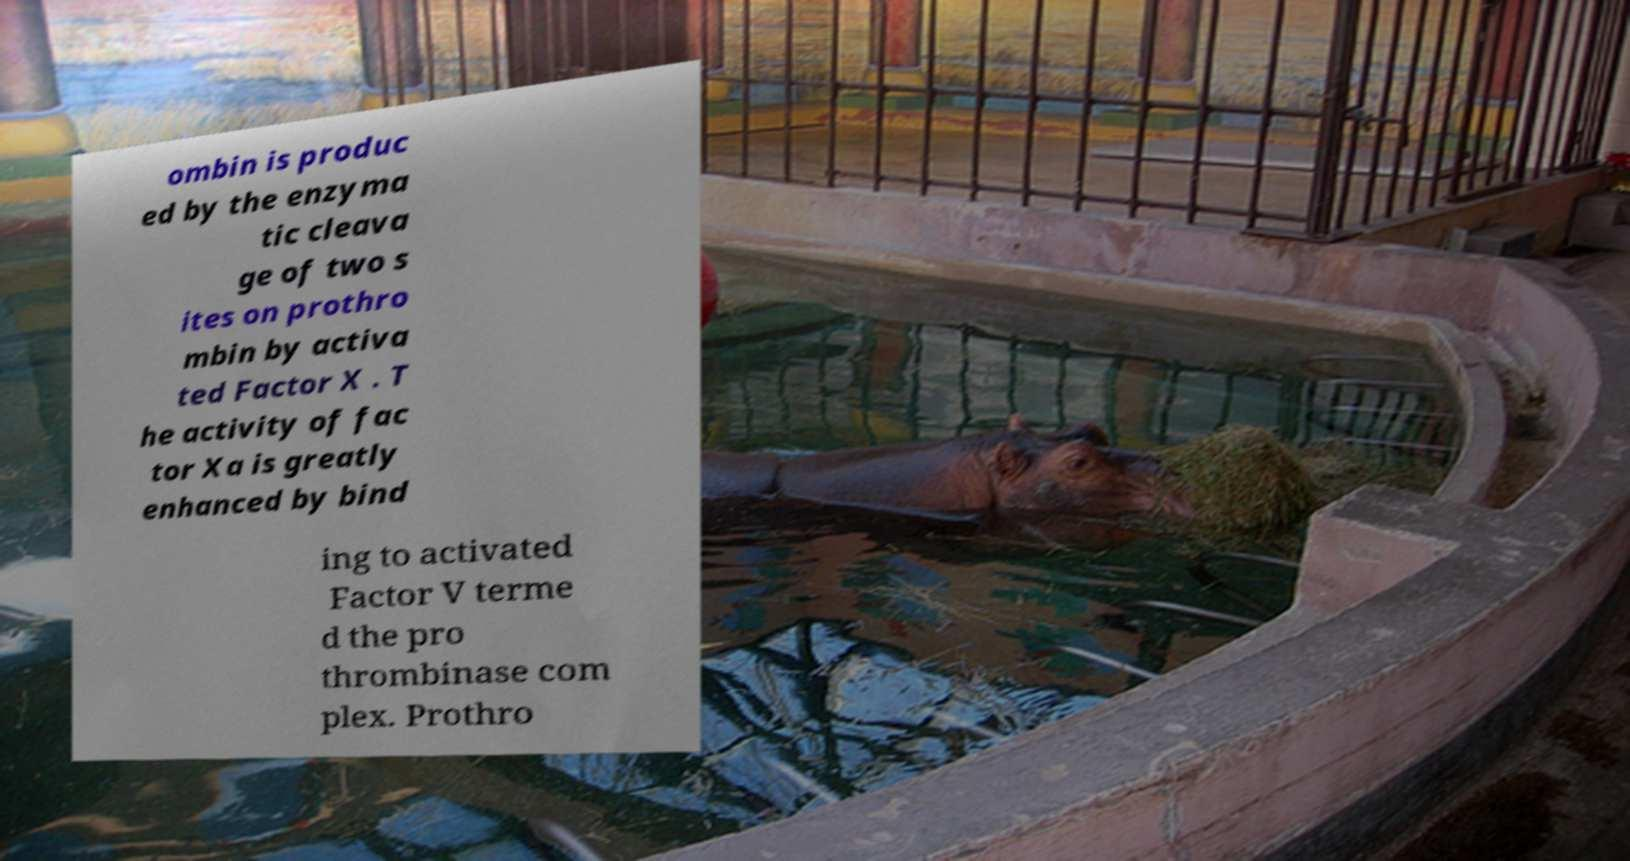Can you read and provide the text displayed in the image?This photo seems to have some interesting text. Can you extract and type it out for me? ombin is produc ed by the enzyma tic cleava ge of two s ites on prothro mbin by activa ted Factor X . T he activity of fac tor Xa is greatly enhanced by bind ing to activated Factor V terme d the pro thrombinase com plex. Prothro 